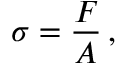Convert formula to latex. <formula><loc_0><loc_0><loc_500><loc_500>\sigma = { \frac { F } { A } } \, ,</formula> 